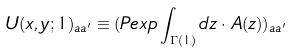Convert formula to latex. <formula><loc_0><loc_0><loc_500><loc_500>U ( x , y ; 1 ) _ { a a ^ { \prime } } \equiv ( P e x p \int _ { \Gamma ( 1 ) } d z \cdot A ( z ) ) _ { a a ^ { \prime } }</formula> 